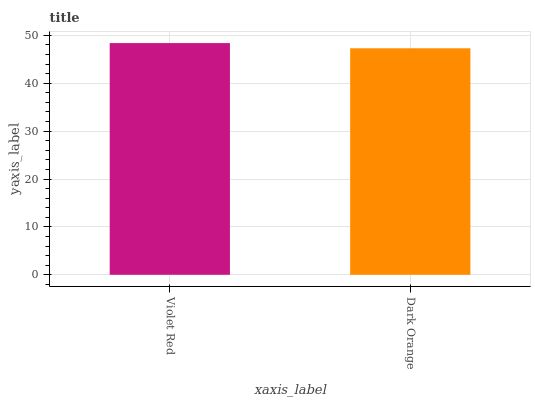Is Dark Orange the minimum?
Answer yes or no. Yes. Is Violet Red the maximum?
Answer yes or no. Yes. Is Dark Orange the maximum?
Answer yes or no. No. Is Violet Red greater than Dark Orange?
Answer yes or no. Yes. Is Dark Orange less than Violet Red?
Answer yes or no. Yes. Is Dark Orange greater than Violet Red?
Answer yes or no. No. Is Violet Red less than Dark Orange?
Answer yes or no. No. Is Violet Red the high median?
Answer yes or no. Yes. Is Dark Orange the low median?
Answer yes or no. Yes. Is Dark Orange the high median?
Answer yes or no. No. Is Violet Red the low median?
Answer yes or no. No. 